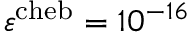<formula> <loc_0><loc_0><loc_500><loc_500>\varepsilon ^ { c h e b } = 1 0 ^ { - 1 6 }</formula> 